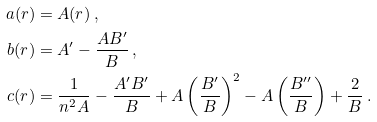Convert formula to latex. <formula><loc_0><loc_0><loc_500><loc_500>a ( r ) & = A ( r ) \, , \\ b ( r ) & = A ^ { \prime } - \frac { A B ^ { \prime } } { B } \, , \\ c ( r ) & = \frac { 1 } { n ^ { 2 } A } - \frac { A ^ { \prime } B ^ { \prime } } { B } + A \left ( \frac { B ^ { \prime } } { B } \right ) ^ { 2 } - A \left ( \frac { B ^ { \prime \prime } } { B } \right ) + \frac { 2 } { B } \, .</formula> 